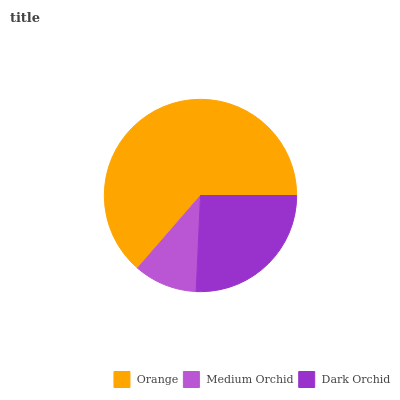Is Medium Orchid the minimum?
Answer yes or no. Yes. Is Orange the maximum?
Answer yes or no. Yes. Is Dark Orchid the minimum?
Answer yes or no. No. Is Dark Orchid the maximum?
Answer yes or no. No. Is Dark Orchid greater than Medium Orchid?
Answer yes or no. Yes. Is Medium Orchid less than Dark Orchid?
Answer yes or no. Yes. Is Medium Orchid greater than Dark Orchid?
Answer yes or no. No. Is Dark Orchid less than Medium Orchid?
Answer yes or no. No. Is Dark Orchid the high median?
Answer yes or no. Yes. Is Dark Orchid the low median?
Answer yes or no. Yes. Is Medium Orchid the high median?
Answer yes or no. No. Is Orange the low median?
Answer yes or no. No. 